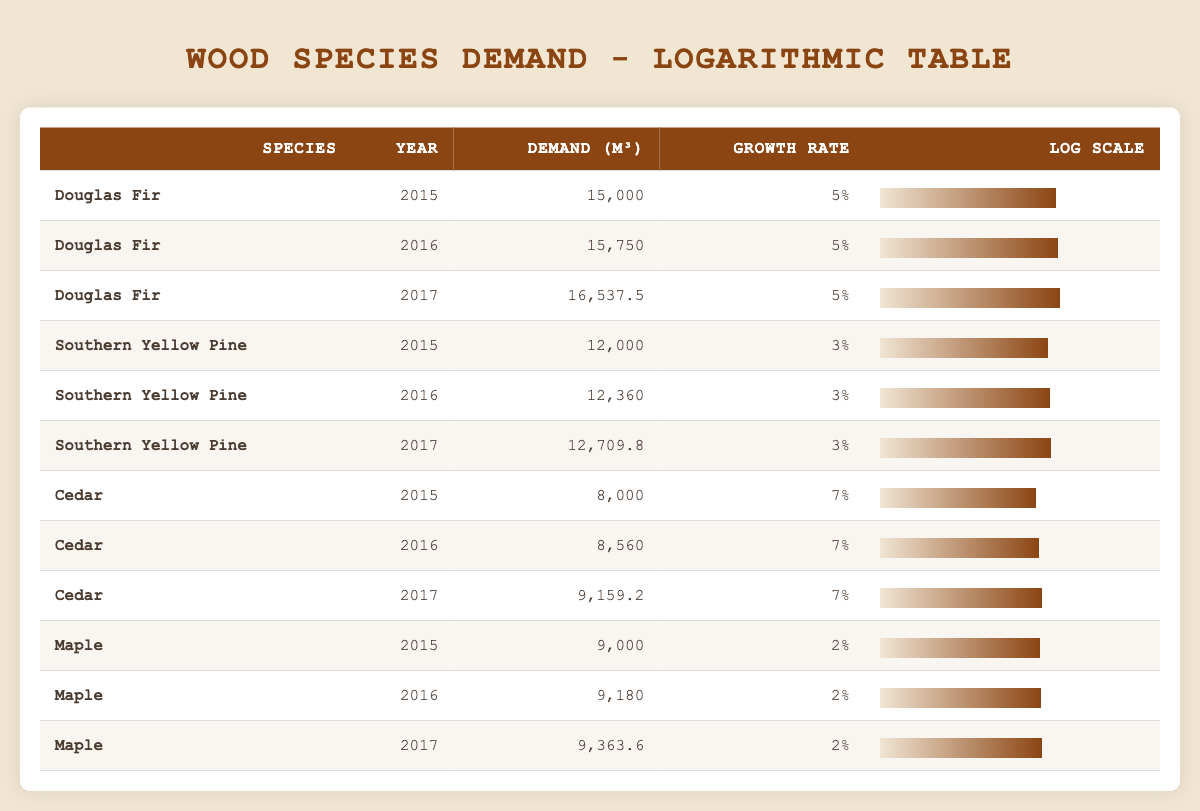What was the demand for Douglas Fir in 2017? The table clearly shows the demand volume for Douglas Fir in 2017 listed as 16,537.5 cubic meters in the respective row.
Answer: 16,537.5 cubic meters What is the growth rate for Southern Yellow Pine in 2016? By looking at the row for Southern Yellow Pine in 2016, the growth rate is stated as 3%.
Answer: 3% Which species had the highest demand in 2015? To find this, we can compare the demand volumes of all species listed in 2015: Douglas Fir (15,000), Southern Yellow Pine (12,000), Cedar (8,000), and Maple (9,000). The highest value is 15,000 cubic meters for Douglas Fir.
Answer: Douglas Fir What was the total demand for Cedar over the years 2015 to 2017? We can sum the demand volumes for Cedar: 8,000 (2015) + 8,560 (2016) + 9,159.2 (2017) = 25,719.2 cubic meters.
Answer: 25,719.2 cubic meters Is the demand for Maple increasing each year? Checking the demand values for Maple, we find 9,000 (2015), 9,180 (2016), and 9,363.6 (2017). Since each subsequent year's demand is higher than the previous, the demand is indeed increasing.
Answer: Yes What is the average demand for Douglas Fir from 2015 to 2017? For Douglas Fir, the demand volumes are 15,000 (2015), 15,750 (2016), and 16,537.5 (2017). To find the average, we add these values (15,000 + 15,750 + 16,537.5 = 47,287.5) and divide by 3, getting 15,762.5 cubic meters.
Answer: 15,762.5 cubic meters What is the total growth rate for Southern Yellow Pine from 2015 to 2017? The growth rates are 3% for each year. Since we want the cumulative growth rate, we can calculate the compound growth over three years. After calculating each year’s impact successively, it results in an effective growth rate of approximately 9.27%.
Answer: 9.27% Was the demand for wood species always higher than 10,000 cubic meters from 2015 to 2017? Analyzing the demand data for each year, we see that Southern Yellow Pine's demand in 2015 was 12,000, but Cedar's demand in 2015 was below 10,000. Therefore, the statement is false.
Answer: No What was the percentage increase in demand for Cedar from 2016 to 2017? The demand for Cedar in 2016 was 8,560 and in 2017 it was 9,159.2. To calculate the percentage increase, use the formula [(New - Old) / Old] * 100, which calculates to [(9,159.2 - 8,560) / 8,560] * 100 = approximately 7.03%.
Answer: 7.03% 